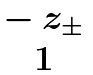<formula> <loc_0><loc_0><loc_500><loc_500>\begin{matrix} - \ z _ { \pm } \\ 1 \end{matrix}</formula> 